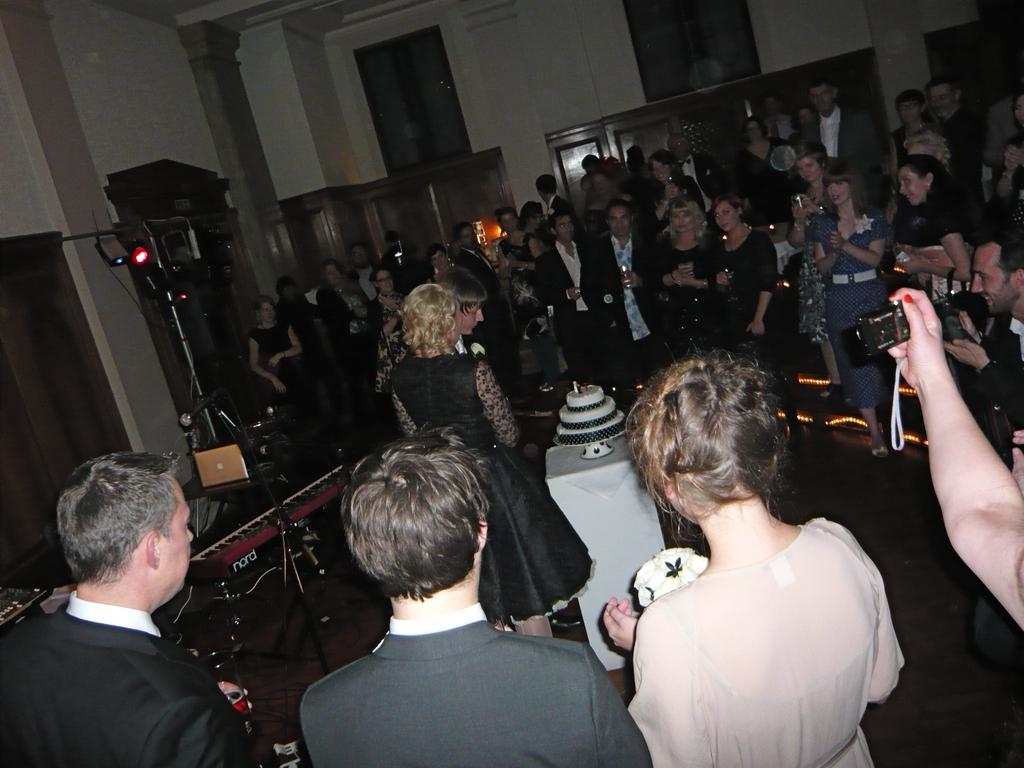What is happening in the image? There is a couple in the image, and they are celebrating their engagement. Who else is present in the image besides the couple? There are people gathered around the couple. What type of texture can be seen on the beef in the image? There is no beef present in the image, so it is not possible to determine its texture. 